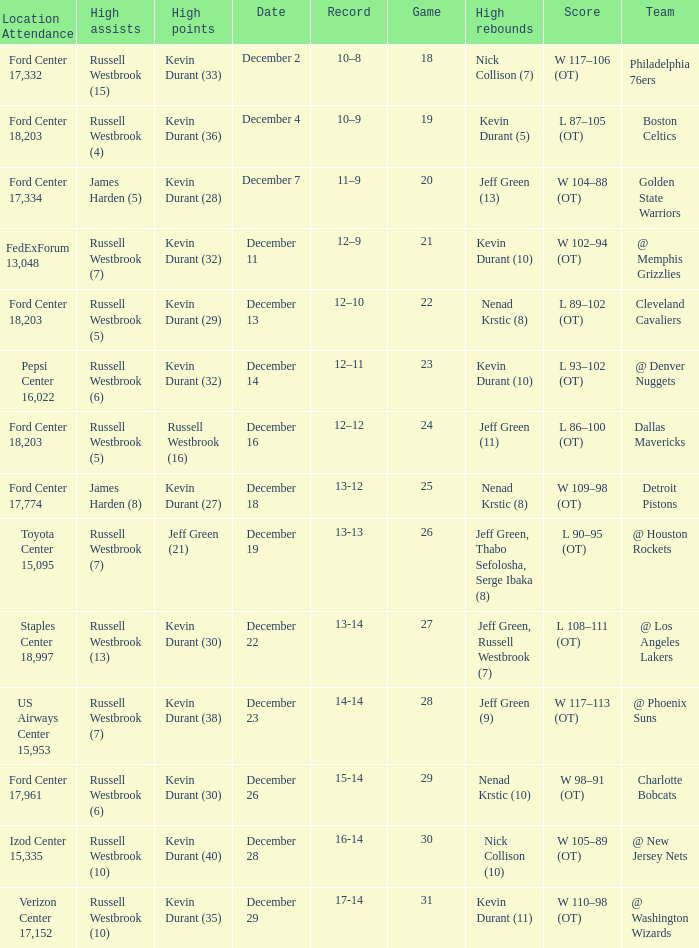Who has high points when toyota center 15,095 is location attendance? Jeff Green (21). 